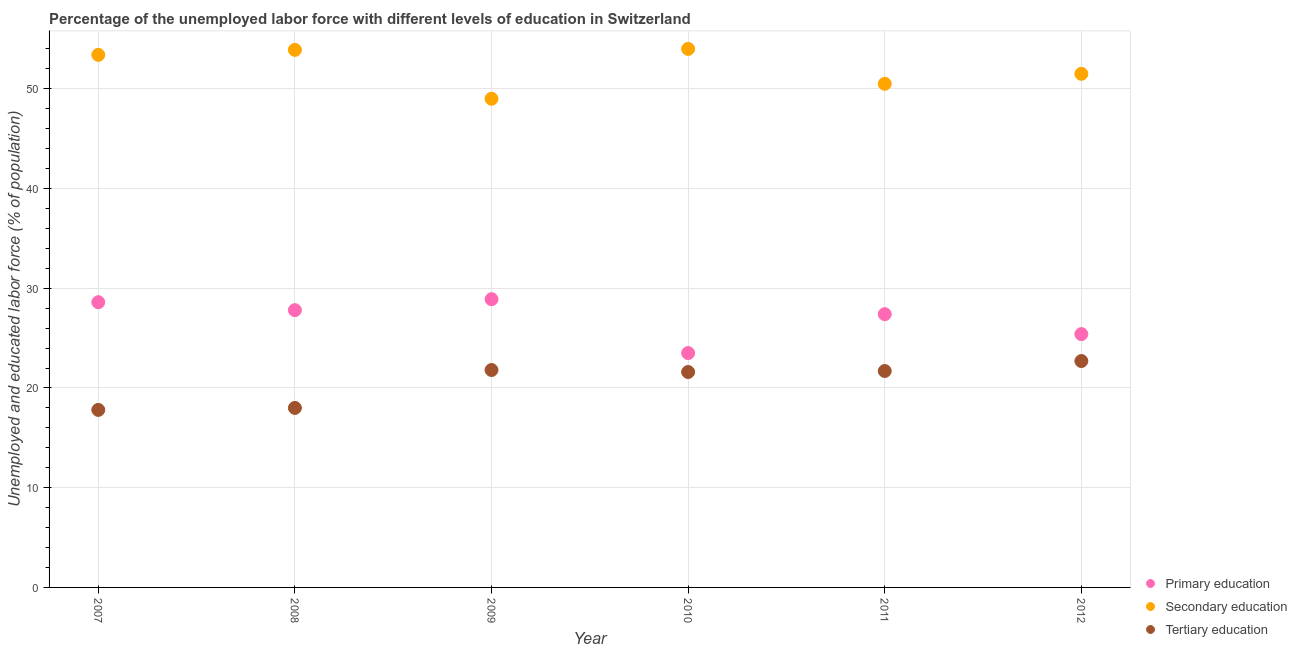How many different coloured dotlines are there?
Provide a succinct answer. 3. What is the percentage of labor force who received primary education in 2007?
Keep it short and to the point. 28.6. Across all years, what is the maximum percentage of labor force who received primary education?
Keep it short and to the point. 28.9. Across all years, what is the minimum percentage of labor force who received secondary education?
Give a very brief answer. 49. In which year was the percentage of labor force who received tertiary education maximum?
Your answer should be very brief. 2012. What is the total percentage of labor force who received secondary education in the graph?
Provide a succinct answer. 312.3. What is the difference between the percentage of labor force who received tertiary education in 2010 and that in 2012?
Make the answer very short. -1.1. What is the difference between the percentage of labor force who received tertiary education in 2010 and the percentage of labor force who received secondary education in 2009?
Offer a terse response. -27.4. What is the average percentage of labor force who received tertiary education per year?
Keep it short and to the point. 20.6. In the year 2008, what is the difference between the percentage of labor force who received primary education and percentage of labor force who received secondary education?
Offer a terse response. -26.1. In how many years, is the percentage of labor force who received secondary education greater than 38 %?
Make the answer very short. 6. What is the ratio of the percentage of labor force who received tertiary education in 2008 to that in 2011?
Your response must be concise. 0.83. What is the difference between the highest and the second highest percentage of labor force who received primary education?
Ensure brevity in your answer.  0.3. What is the difference between the highest and the lowest percentage of labor force who received tertiary education?
Offer a terse response. 4.9. Is the sum of the percentage of labor force who received primary education in 2007 and 2012 greater than the maximum percentage of labor force who received tertiary education across all years?
Ensure brevity in your answer.  Yes. Is it the case that in every year, the sum of the percentage of labor force who received primary education and percentage of labor force who received secondary education is greater than the percentage of labor force who received tertiary education?
Your answer should be compact. Yes. Is the percentage of labor force who received secondary education strictly greater than the percentage of labor force who received tertiary education over the years?
Keep it short and to the point. Yes. How many dotlines are there?
Ensure brevity in your answer.  3. What is the difference between two consecutive major ticks on the Y-axis?
Provide a short and direct response. 10. Does the graph contain any zero values?
Provide a short and direct response. No. Does the graph contain grids?
Your answer should be very brief. Yes. Where does the legend appear in the graph?
Your answer should be compact. Bottom right. How many legend labels are there?
Keep it short and to the point. 3. How are the legend labels stacked?
Your answer should be compact. Vertical. What is the title of the graph?
Keep it short and to the point. Percentage of the unemployed labor force with different levels of education in Switzerland. What is the label or title of the Y-axis?
Offer a terse response. Unemployed and educated labor force (% of population). What is the Unemployed and educated labor force (% of population) in Primary education in 2007?
Give a very brief answer. 28.6. What is the Unemployed and educated labor force (% of population) in Secondary education in 2007?
Ensure brevity in your answer.  53.4. What is the Unemployed and educated labor force (% of population) of Tertiary education in 2007?
Keep it short and to the point. 17.8. What is the Unemployed and educated labor force (% of population) of Primary education in 2008?
Keep it short and to the point. 27.8. What is the Unemployed and educated labor force (% of population) in Secondary education in 2008?
Ensure brevity in your answer.  53.9. What is the Unemployed and educated labor force (% of population) in Primary education in 2009?
Provide a short and direct response. 28.9. What is the Unemployed and educated labor force (% of population) of Secondary education in 2009?
Make the answer very short. 49. What is the Unemployed and educated labor force (% of population) of Tertiary education in 2009?
Offer a terse response. 21.8. What is the Unemployed and educated labor force (% of population) of Primary education in 2010?
Your answer should be very brief. 23.5. What is the Unemployed and educated labor force (% of population) of Tertiary education in 2010?
Your response must be concise. 21.6. What is the Unemployed and educated labor force (% of population) of Primary education in 2011?
Keep it short and to the point. 27.4. What is the Unemployed and educated labor force (% of population) in Secondary education in 2011?
Make the answer very short. 50.5. What is the Unemployed and educated labor force (% of population) of Tertiary education in 2011?
Make the answer very short. 21.7. What is the Unemployed and educated labor force (% of population) of Primary education in 2012?
Provide a succinct answer. 25.4. What is the Unemployed and educated labor force (% of population) of Secondary education in 2012?
Offer a very short reply. 51.5. What is the Unemployed and educated labor force (% of population) of Tertiary education in 2012?
Your answer should be compact. 22.7. Across all years, what is the maximum Unemployed and educated labor force (% of population) in Primary education?
Provide a succinct answer. 28.9. Across all years, what is the maximum Unemployed and educated labor force (% of population) of Tertiary education?
Offer a very short reply. 22.7. Across all years, what is the minimum Unemployed and educated labor force (% of population) in Secondary education?
Offer a terse response. 49. Across all years, what is the minimum Unemployed and educated labor force (% of population) in Tertiary education?
Your answer should be compact. 17.8. What is the total Unemployed and educated labor force (% of population) in Primary education in the graph?
Your answer should be compact. 161.6. What is the total Unemployed and educated labor force (% of population) in Secondary education in the graph?
Your response must be concise. 312.3. What is the total Unemployed and educated labor force (% of population) in Tertiary education in the graph?
Your answer should be very brief. 123.6. What is the difference between the Unemployed and educated labor force (% of population) of Primary education in 2007 and that in 2008?
Ensure brevity in your answer.  0.8. What is the difference between the Unemployed and educated labor force (% of population) of Tertiary education in 2007 and that in 2008?
Your answer should be very brief. -0.2. What is the difference between the Unemployed and educated labor force (% of population) in Primary education in 2007 and that in 2009?
Ensure brevity in your answer.  -0.3. What is the difference between the Unemployed and educated labor force (% of population) in Tertiary education in 2007 and that in 2009?
Your answer should be very brief. -4. What is the difference between the Unemployed and educated labor force (% of population) in Secondary education in 2007 and that in 2010?
Your answer should be very brief. -0.6. What is the difference between the Unemployed and educated labor force (% of population) in Tertiary education in 2007 and that in 2010?
Keep it short and to the point. -3.8. What is the difference between the Unemployed and educated labor force (% of population) of Primary education in 2007 and that in 2011?
Make the answer very short. 1.2. What is the difference between the Unemployed and educated labor force (% of population) in Primary education in 2007 and that in 2012?
Offer a very short reply. 3.2. What is the difference between the Unemployed and educated labor force (% of population) of Tertiary education in 2007 and that in 2012?
Give a very brief answer. -4.9. What is the difference between the Unemployed and educated labor force (% of population) in Secondary education in 2008 and that in 2009?
Your answer should be very brief. 4.9. What is the difference between the Unemployed and educated labor force (% of population) in Primary education in 2008 and that in 2010?
Your answer should be very brief. 4.3. What is the difference between the Unemployed and educated labor force (% of population) in Secondary education in 2008 and that in 2012?
Ensure brevity in your answer.  2.4. What is the difference between the Unemployed and educated labor force (% of population) of Tertiary education in 2008 and that in 2012?
Offer a terse response. -4.7. What is the difference between the Unemployed and educated labor force (% of population) in Secondary education in 2009 and that in 2010?
Your answer should be compact. -5. What is the difference between the Unemployed and educated labor force (% of population) in Secondary education in 2009 and that in 2011?
Ensure brevity in your answer.  -1.5. What is the difference between the Unemployed and educated labor force (% of population) in Tertiary education in 2009 and that in 2011?
Your answer should be very brief. 0.1. What is the difference between the Unemployed and educated labor force (% of population) of Tertiary education in 2009 and that in 2012?
Provide a succinct answer. -0.9. What is the difference between the Unemployed and educated labor force (% of population) of Primary education in 2010 and that in 2011?
Ensure brevity in your answer.  -3.9. What is the difference between the Unemployed and educated labor force (% of population) of Secondary education in 2010 and that in 2011?
Ensure brevity in your answer.  3.5. What is the difference between the Unemployed and educated labor force (% of population) in Tertiary education in 2010 and that in 2011?
Offer a terse response. -0.1. What is the difference between the Unemployed and educated labor force (% of population) in Primary education in 2010 and that in 2012?
Provide a short and direct response. -1.9. What is the difference between the Unemployed and educated labor force (% of population) of Tertiary education in 2010 and that in 2012?
Offer a very short reply. -1.1. What is the difference between the Unemployed and educated labor force (% of population) of Secondary education in 2011 and that in 2012?
Your response must be concise. -1. What is the difference between the Unemployed and educated labor force (% of population) of Primary education in 2007 and the Unemployed and educated labor force (% of population) of Secondary education in 2008?
Make the answer very short. -25.3. What is the difference between the Unemployed and educated labor force (% of population) in Secondary education in 2007 and the Unemployed and educated labor force (% of population) in Tertiary education in 2008?
Ensure brevity in your answer.  35.4. What is the difference between the Unemployed and educated labor force (% of population) in Primary education in 2007 and the Unemployed and educated labor force (% of population) in Secondary education in 2009?
Provide a short and direct response. -20.4. What is the difference between the Unemployed and educated labor force (% of population) of Primary education in 2007 and the Unemployed and educated labor force (% of population) of Tertiary education in 2009?
Make the answer very short. 6.8. What is the difference between the Unemployed and educated labor force (% of population) in Secondary education in 2007 and the Unemployed and educated labor force (% of population) in Tertiary education in 2009?
Offer a terse response. 31.6. What is the difference between the Unemployed and educated labor force (% of population) in Primary education in 2007 and the Unemployed and educated labor force (% of population) in Secondary education in 2010?
Ensure brevity in your answer.  -25.4. What is the difference between the Unemployed and educated labor force (% of population) in Primary education in 2007 and the Unemployed and educated labor force (% of population) in Tertiary education in 2010?
Make the answer very short. 7. What is the difference between the Unemployed and educated labor force (% of population) of Secondary education in 2007 and the Unemployed and educated labor force (% of population) of Tertiary education in 2010?
Make the answer very short. 31.8. What is the difference between the Unemployed and educated labor force (% of population) of Primary education in 2007 and the Unemployed and educated labor force (% of population) of Secondary education in 2011?
Ensure brevity in your answer.  -21.9. What is the difference between the Unemployed and educated labor force (% of population) in Primary education in 2007 and the Unemployed and educated labor force (% of population) in Tertiary education in 2011?
Your answer should be compact. 6.9. What is the difference between the Unemployed and educated labor force (% of population) in Secondary education in 2007 and the Unemployed and educated labor force (% of population) in Tertiary education in 2011?
Give a very brief answer. 31.7. What is the difference between the Unemployed and educated labor force (% of population) of Primary education in 2007 and the Unemployed and educated labor force (% of population) of Secondary education in 2012?
Your answer should be very brief. -22.9. What is the difference between the Unemployed and educated labor force (% of population) of Secondary education in 2007 and the Unemployed and educated labor force (% of population) of Tertiary education in 2012?
Keep it short and to the point. 30.7. What is the difference between the Unemployed and educated labor force (% of population) in Primary education in 2008 and the Unemployed and educated labor force (% of population) in Secondary education in 2009?
Provide a succinct answer. -21.2. What is the difference between the Unemployed and educated labor force (% of population) in Primary education in 2008 and the Unemployed and educated labor force (% of population) in Tertiary education in 2009?
Ensure brevity in your answer.  6. What is the difference between the Unemployed and educated labor force (% of population) in Secondary education in 2008 and the Unemployed and educated labor force (% of population) in Tertiary education in 2009?
Provide a short and direct response. 32.1. What is the difference between the Unemployed and educated labor force (% of population) in Primary education in 2008 and the Unemployed and educated labor force (% of population) in Secondary education in 2010?
Offer a terse response. -26.2. What is the difference between the Unemployed and educated labor force (% of population) of Primary education in 2008 and the Unemployed and educated labor force (% of population) of Tertiary education in 2010?
Provide a succinct answer. 6.2. What is the difference between the Unemployed and educated labor force (% of population) of Secondary education in 2008 and the Unemployed and educated labor force (% of population) of Tertiary education in 2010?
Ensure brevity in your answer.  32.3. What is the difference between the Unemployed and educated labor force (% of population) in Primary education in 2008 and the Unemployed and educated labor force (% of population) in Secondary education in 2011?
Your answer should be very brief. -22.7. What is the difference between the Unemployed and educated labor force (% of population) in Primary education in 2008 and the Unemployed and educated labor force (% of population) in Tertiary education in 2011?
Offer a very short reply. 6.1. What is the difference between the Unemployed and educated labor force (% of population) of Secondary education in 2008 and the Unemployed and educated labor force (% of population) of Tertiary education in 2011?
Your answer should be compact. 32.2. What is the difference between the Unemployed and educated labor force (% of population) of Primary education in 2008 and the Unemployed and educated labor force (% of population) of Secondary education in 2012?
Your answer should be compact. -23.7. What is the difference between the Unemployed and educated labor force (% of population) of Primary education in 2008 and the Unemployed and educated labor force (% of population) of Tertiary education in 2012?
Offer a very short reply. 5.1. What is the difference between the Unemployed and educated labor force (% of population) of Secondary education in 2008 and the Unemployed and educated labor force (% of population) of Tertiary education in 2012?
Your response must be concise. 31.2. What is the difference between the Unemployed and educated labor force (% of population) in Primary education in 2009 and the Unemployed and educated labor force (% of population) in Secondary education in 2010?
Offer a terse response. -25.1. What is the difference between the Unemployed and educated labor force (% of population) in Primary education in 2009 and the Unemployed and educated labor force (% of population) in Tertiary education in 2010?
Your answer should be very brief. 7.3. What is the difference between the Unemployed and educated labor force (% of population) in Secondary education in 2009 and the Unemployed and educated labor force (% of population) in Tertiary education in 2010?
Make the answer very short. 27.4. What is the difference between the Unemployed and educated labor force (% of population) in Primary education in 2009 and the Unemployed and educated labor force (% of population) in Secondary education in 2011?
Ensure brevity in your answer.  -21.6. What is the difference between the Unemployed and educated labor force (% of population) of Primary education in 2009 and the Unemployed and educated labor force (% of population) of Tertiary education in 2011?
Keep it short and to the point. 7.2. What is the difference between the Unemployed and educated labor force (% of population) in Secondary education in 2009 and the Unemployed and educated labor force (% of population) in Tertiary education in 2011?
Offer a very short reply. 27.3. What is the difference between the Unemployed and educated labor force (% of population) in Primary education in 2009 and the Unemployed and educated labor force (% of population) in Secondary education in 2012?
Give a very brief answer. -22.6. What is the difference between the Unemployed and educated labor force (% of population) of Secondary education in 2009 and the Unemployed and educated labor force (% of population) of Tertiary education in 2012?
Give a very brief answer. 26.3. What is the difference between the Unemployed and educated labor force (% of population) in Secondary education in 2010 and the Unemployed and educated labor force (% of population) in Tertiary education in 2011?
Your answer should be very brief. 32.3. What is the difference between the Unemployed and educated labor force (% of population) of Secondary education in 2010 and the Unemployed and educated labor force (% of population) of Tertiary education in 2012?
Offer a very short reply. 31.3. What is the difference between the Unemployed and educated labor force (% of population) in Primary education in 2011 and the Unemployed and educated labor force (% of population) in Secondary education in 2012?
Your answer should be compact. -24.1. What is the difference between the Unemployed and educated labor force (% of population) of Primary education in 2011 and the Unemployed and educated labor force (% of population) of Tertiary education in 2012?
Give a very brief answer. 4.7. What is the difference between the Unemployed and educated labor force (% of population) of Secondary education in 2011 and the Unemployed and educated labor force (% of population) of Tertiary education in 2012?
Keep it short and to the point. 27.8. What is the average Unemployed and educated labor force (% of population) in Primary education per year?
Make the answer very short. 26.93. What is the average Unemployed and educated labor force (% of population) of Secondary education per year?
Provide a short and direct response. 52.05. What is the average Unemployed and educated labor force (% of population) of Tertiary education per year?
Make the answer very short. 20.6. In the year 2007, what is the difference between the Unemployed and educated labor force (% of population) in Primary education and Unemployed and educated labor force (% of population) in Secondary education?
Make the answer very short. -24.8. In the year 2007, what is the difference between the Unemployed and educated labor force (% of population) of Secondary education and Unemployed and educated labor force (% of population) of Tertiary education?
Give a very brief answer. 35.6. In the year 2008, what is the difference between the Unemployed and educated labor force (% of population) in Primary education and Unemployed and educated labor force (% of population) in Secondary education?
Give a very brief answer. -26.1. In the year 2008, what is the difference between the Unemployed and educated labor force (% of population) of Primary education and Unemployed and educated labor force (% of population) of Tertiary education?
Ensure brevity in your answer.  9.8. In the year 2008, what is the difference between the Unemployed and educated labor force (% of population) in Secondary education and Unemployed and educated labor force (% of population) in Tertiary education?
Offer a very short reply. 35.9. In the year 2009, what is the difference between the Unemployed and educated labor force (% of population) in Primary education and Unemployed and educated labor force (% of population) in Secondary education?
Your answer should be very brief. -20.1. In the year 2009, what is the difference between the Unemployed and educated labor force (% of population) of Secondary education and Unemployed and educated labor force (% of population) of Tertiary education?
Your response must be concise. 27.2. In the year 2010, what is the difference between the Unemployed and educated labor force (% of population) of Primary education and Unemployed and educated labor force (% of population) of Secondary education?
Offer a terse response. -30.5. In the year 2010, what is the difference between the Unemployed and educated labor force (% of population) of Secondary education and Unemployed and educated labor force (% of population) of Tertiary education?
Provide a short and direct response. 32.4. In the year 2011, what is the difference between the Unemployed and educated labor force (% of population) in Primary education and Unemployed and educated labor force (% of population) in Secondary education?
Ensure brevity in your answer.  -23.1. In the year 2011, what is the difference between the Unemployed and educated labor force (% of population) of Primary education and Unemployed and educated labor force (% of population) of Tertiary education?
Provide a short and direct response. 5.7. In the year 2011, what is the difference between the Unemployed and educated labor force (% of population) in Secondary education and Unemployed and educated labor force (% of population) in Tertiary education?
Your answer should be compact. 28.8. In the year 2012, what is the difference between the Unemployed and educated labor force (% of population) in Primary education and Unemployed and educated labor force (% of population) in Secondary education?
Offer a very short reply. -26.1. In the year 2012, what is the difference between the Unemployed and educated labor force (% of population) in Secondary education and Unemployed and educated labor force (% of population) in Tertiary education?
Your answer should be very brief. 28.8. What is the ratio of the Unemployed and educated labor force (% of population) of Primary education in 2007 to that in 2008?
Your response must be concise. 1.03. What is the ratio of the Unemployed and educated labor force (% of population) in Tertiary education in 2007 to that in 2008?
Your response must be concise. 0.99. What is the ratio of the Unemployed and educated labor force (% of population) of Primary education in 2007 to that in 2009?
Provide a succinct answer. 0.99. What is the ratio of the Unemployed and educated labor force (% of population) of Secondary education in 2007 to that in 2009?
Offer a very short reply. 1.09. What is the ratio of the Unemployed and educated labor force (% of population) in Tertiary education in 2007 to that in 2009?
Make the answer very short. 0.82. What is the ratio of the Unemployed and educated labor force (% of population) in Primary education in 2007 to that in 2010?
Your response must be concise. 1.22. What is the ratio of the Unemployed and educated labor force (% of population) of Secondary education in 2007 to that in 2010?
Your response must be concise. 0.99. What is the ratio of the Unemployed and educated labor force (% of population) of Tertiary education in 2007 to that in 2010?
Give a very brief answer. 0.82. What is the ratio of the Unemployed and educated labor force (% of population) in Primary education in 2007 to that in 2011?
Provide a succinct answer. 1.04. What is the ratio of the Unemployed and educated labor force (% of population) in Secondary education in 2007 to that in 2011?
Make the answer very short. 1.06. What is the ratio of the Unemployed and educated labor force (% of population) of Tertiary education in 2007 to that in 2011?
Give a very brief answer. 0.82. What is the ratio of the Unemployed and educated labor force (% of population) of Primary education in 2007 to that in 2012?
Offer a terse response. 1.13. What is the ratio of the Unemployed and educated labor force (% of population) of Secondary education in 2007 to that in 2012?
Provide a short and direct response. 1.04. What is the ratio of the Unemployed and educated labor force (% of population) of Tertiary education in 2007 to that in 2012?
Your response must be concise. 0.78. What is the ratio of the Unemployed and educated labor force (% of population) in Primary education in 2008 to that in 2009?
Offer a terse response. 0.96. What is the ratio of the Unemployed and educated labor force (% of population) in Tertiary education in 2008 to that in 2009?
Ensure brevity in your answer.  0.83. What is the ratio of the Unemployed and educated labor force (% of population) in Primary education in 2008 to that in 2010?
Your answer should be very brief. 1.18. What is the ratio of the Unemployed and educated labor force (% of population) of Secondary education in 2008 to that in 2010?
Provide a succinct answer. 1. What is the ratio of the Unemployed and educated labor force (% of population) in Tertiary education in 2008 to that in 2010?
Ensure brevity in your answer.  0.83. What is the ratio of the Unemployed and educated labor force (% of population) in Primary education in 2008 to that in 2011?
Offer a very short reply. 1.01. What is the ratio of the Unemployed and educated labor force (% of population) of Secondary education in 2008 to that in 2011?
Offer a terse response. 1.07. What is the ratio of the Unemployed and educated labor force (% of population) of Tertiary education in 2008 to that in 2011?
Make the answer very short. 0.83. What is the ratio of the Unemployed and educated labor force (% of population) in Primary education in 2008 to that in 2012?
Make the answer very short. 1.09. What is the ratio of the Unemployed and educated labor force (% of population) in Secondary education in 2008 to that in 2012?
Keep it short and to the point. 1.05. What is the ratio of the Unemployed and educated labor force (% of population) of Tertiary education in 2008 to that in 2012?
Make the answer very short. 0.79. What is the ratio of the Unemployed and educated labor force (% of population) of Primary education in 2009 to that in 2010?
Make the answer very short. 1.23. What is the ratio of the Unemployed and educated labor force (% of population) in Secondary education in 2009 to that in 2010?
Your answer should be very brief. 0.91. What is the ratio of the Unemployed and educated labor force (% of population) in Tertiary education in 2009 to that in 2010?
Your answer should be very brief. 1.01. What is the ratio of the Unemployed and educated labor force (% of population) of Primary education in 2009 to that in 2011?
Give a very brief answer. 1.05. What is the ratio of the Unemployed and educated labor force (% of population) in Secondary education in 2009 to that in 2011?
Provide a short and direct response. 0.97. What is the ratio of the Unemployed and educated labor force (% of population) in Primary education in 2009 to that in 2012?
Offer a terse response. 1.14. What is the ratio of the Unemployed and educated labor force (% of population) in Secondary education in 2009 to that in 2012?
Give a very brief answer. 0.95. What is the ratio of the Unemployed and educated labor force (% of population) in Tertiary education in 2009 to that in 2012?
Your answer should be compact. 0.96. What is the ratio of the Unemployed and educated labor force (% of population) in Primary education in 2010 to that in 2011?
Offer a terse response. 0.86. What is the ratio of the Unemployed and educated labor force (% of population) in Secondary education in 2010 to that in 2011?
Offer a terse response. 1.07. What is the ratio of the Unemployed and educated labor force (% of population) of Primary education in 2010 to that in 2012?
Keep it short and to the point. 0.93. What is the ratio of the Unemployed and educated labor force (% of population) in Secondary education in 2010 to that in 2012?
Your answer should be very brief. 1.05. What is the ratio of the Unemployed and educated labor force (% of population) in Tertiary education in 2010 to that in 2012?
Offer a very short reply. 0.95. What is the ratio of the Unemployed and educated labor force (% of population) in Primary education in 2011 to that in 2012?
Offer a very short reply. 1.08. What is the ratio of the Unemployed and educated labor force (% of population) in Secondary education in 2011 to that in 2012?
Provide a short and direct response. 0.98. What is the ratio of the Unemployed and educated labor force (% of population) of Tertiary education in 2011 to that in 2012?
Your answer should be compact. 0.96. What is the difference between the highest and the lowest Unemployed and educated labor force (% of population) of Primary education?
Ensure brevity in your answer.  5.4. What is the difference between the highest and the lowest Unemployed and educated labor force (% of population) in Secondary education?
Provide a succinct answer. 5. 